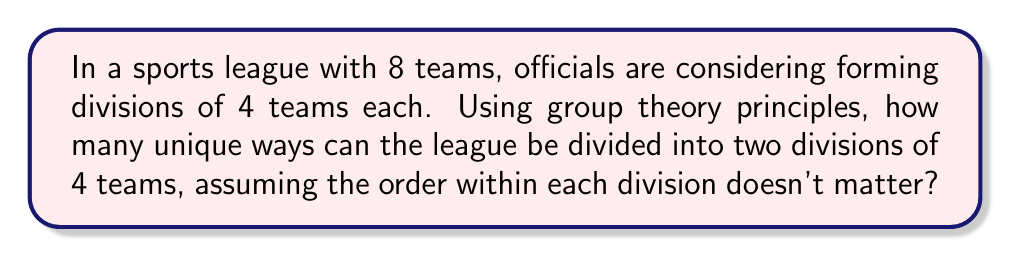Give your solution to this math problem. To solve this problem, we can use concepts from group theory, specifically the idea of partitioning a set. Let's approach this step-by-step:

1) We have a set of 8 teams, and we want to partition it into two subsets of 4 teams each.

2) This is equivalent to choosing 4 teams for the first division, as the remaining 4 will automatically form the second division.

3) The number of ways to choose 4 teams from 8 is given by the combination formula:

   $$\binom{8}{4} = \frac{8!}{4!(8-4)!} = \frac{8!}{4!4!}$$

4) Let's calculate this:
   
   $$\frac{8 * 7 * 6 * 5 * 4!}{4! * 4 * 3 * 2 * 1} = \frac{1680}{24} = 70$$

5) However, this counts each division twice. For example, (A,B,C,D)(E,F,G,H) and (E,F,G,H)(A,B,C,D) are considered the same division in our problem.

6) To account for this, we need to divide our result by 2:

   $$\frac{70}{2} = 35$$

This approach uses the concept of orbit-stabilizer theorem from group theory, where we're essentially counting the orbits under the action of the symmetric group $S_2$ (which swaps the two divisions) on the set of all possible divisions.
Answer: There are 35 unique ways to divide the 8-team league into two divisions of 4 teams each. 